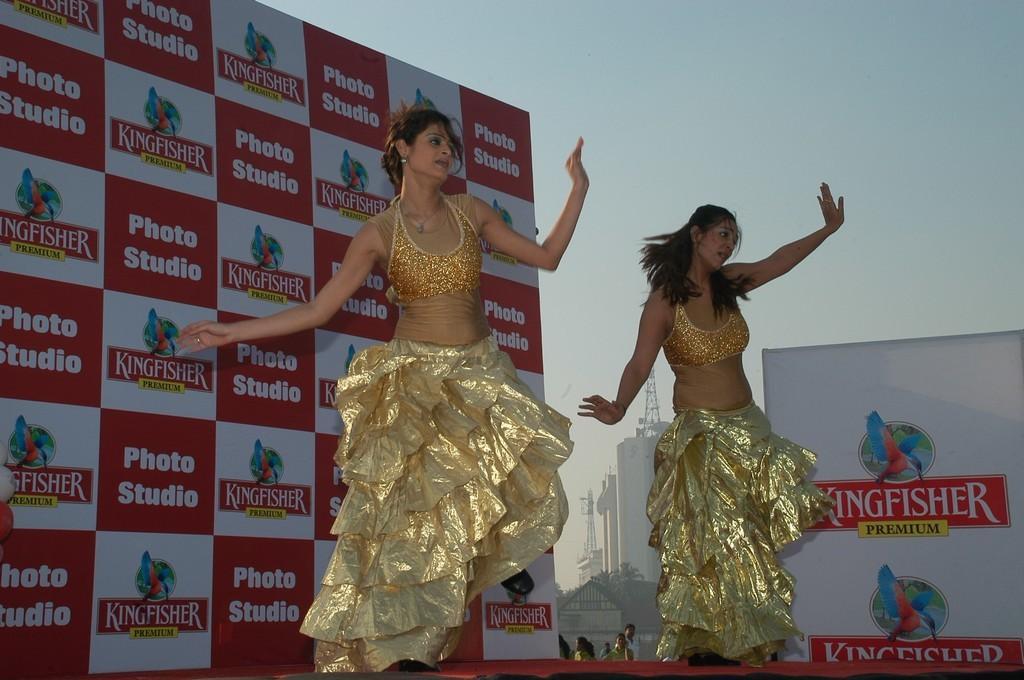Please provide a concise description of this image. In this image we can see two women are dancing on the floor. In the background we can see hoardings, buildings, towers, few people, and sky. 